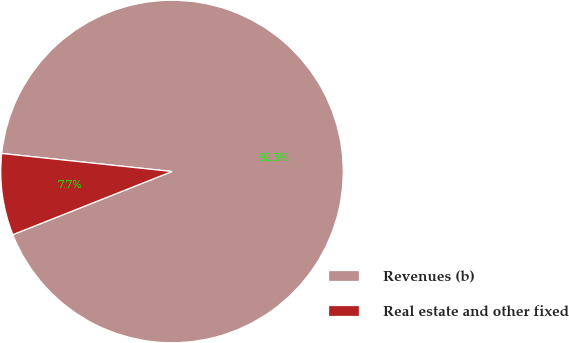Convert chart. <chart><loc_0><loc_0><loc_500><loc_500><pie_chart><fcel>Revenues (b)<fcel>Real estate and other fixed<nl><fcel>92.31%<fcel>7.69%<nl></chart> 